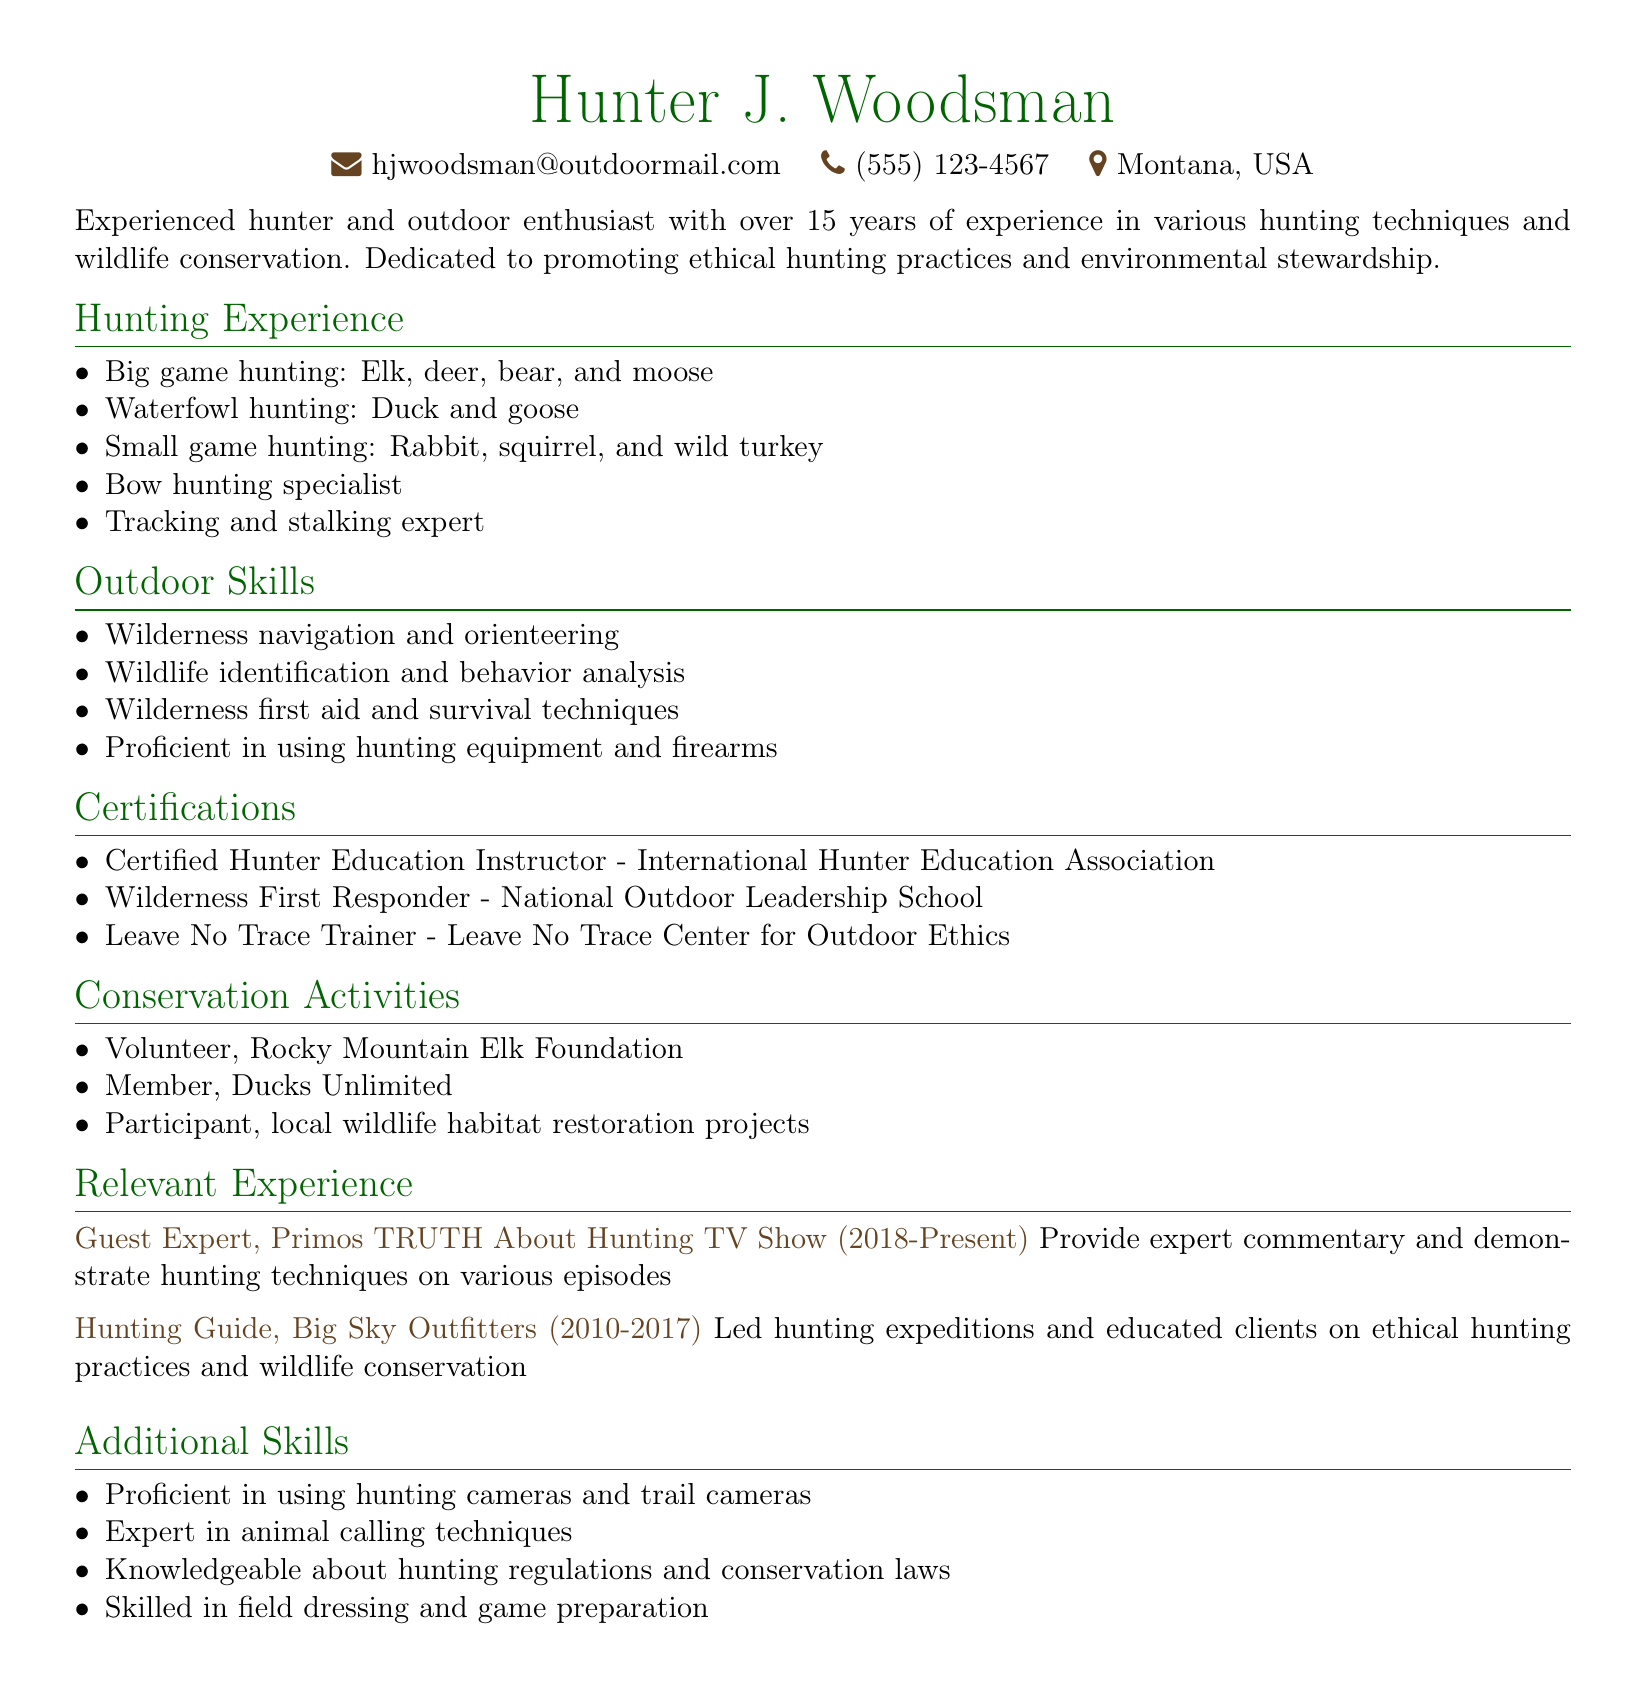what is the name of the individual? The name of the individual is listed at the top of the document.
Answer: Hunter J. Woodsman how many years of hunting experience does the individual have? This information is provided in the summary section of the document.
Answer: over 15 years what type of game does the individual specialize in for bow hunting? This information can be found in the hunting experience section.
Answer: big game what certification does the individual have from the International Hunter Education Association? This is specified in the certifications section of the document.
Answer: Certified Hunter Education Instructor which TV show features the individual as a guest expert? This information is found in the relevant experience section.
Answer: Primos TRUTH About Hunting TV Show what role did the individual have at Big Sky Outfitters? The individual’s position is mentioned in the relevant experience section.
Answer: Hunting Guide how many conservation activities does the individual participate in? This is indicated by the different entries in the conservation activities section.
Answer: three what skill is the individual an expert in related to animals? The respective skill is detailed in the additional skills section.
Answer: animal calling techniques what certification does the individual hold regarding wilderness first aid? This information is provided in the certifications section of the document.
Answer: Wilderness First Responder 